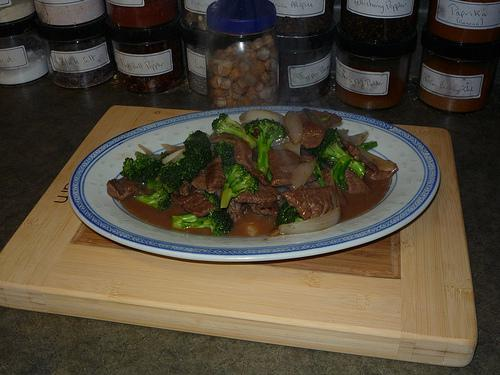Question: where was the photo taken?
Choices:
A. At the beach.
B. Yard.
C. Hotel.
D. On the counter.
Answer with the letter. Answer: D Question: how many plates are there?
Choices:
A. Four.
B. Two.
C. Three.
D. One.
Answer with the letter. Answer: D Question: how many jars are there?
Choices:
A. Twenty.
B. Thirty.
C. Five.
D. Fifteen.
Answer with the letter. Answer: D Question: what surface is everything on?
Choices:
A. Table.
B. A counter.
C. Wood.
D. Plastic.
Answer with the letter. Answer: B Question: what type of meat is there?
Choices:
A. Chicken.
B. Seafood.
C. Pork.
D. Beef.
Answer with the letter. Answer: D Question: what type of green vegetable is there?
Choices:
A. Green beans.
B. Sweet peas.
C. Broccoli.
D. Spinach.
Answer with the letter. Answer: C 